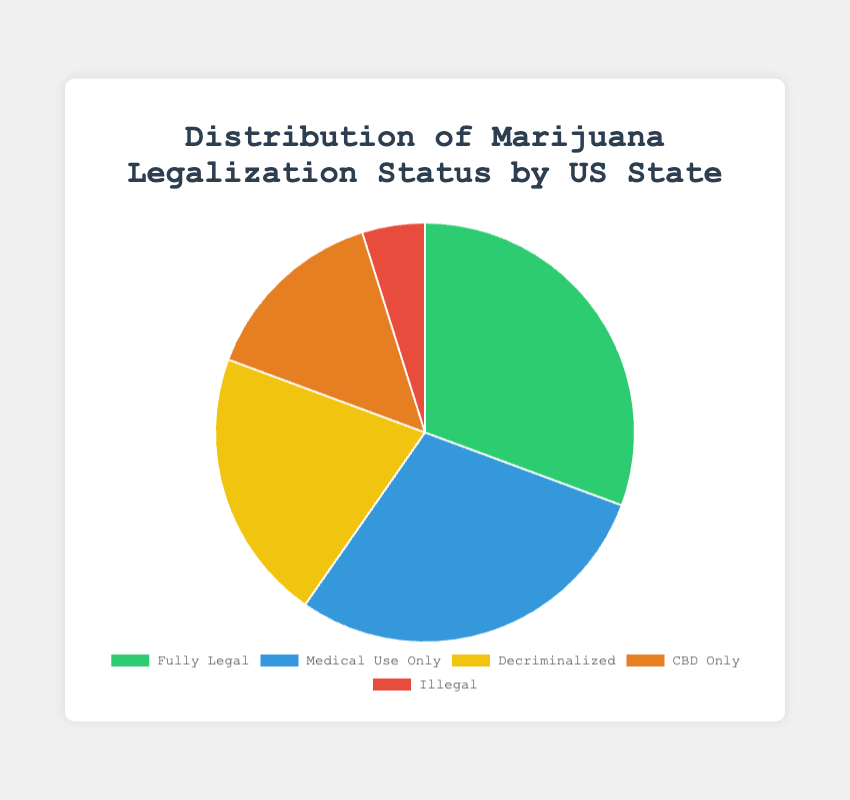What's the proportion of states where marijuana is fully legal compared to those where it's illegal? To find the proportion, compare the number of states where marijuana is fully legal (19) with those where it is illegal (3). The proportion is found by dividing the number of fully legal states by the number of illegal states. \( \frac{19}{3} \approx 6.33 \)
Answer: 6.33 Which category has the highest number of states? The category with the highest number has the biggest section in the pie chart. From the data, "Fully Legal" has the highest count with 19 states.
Answer: Fully Legal How many more states have medical use only legalization compared to those where it's decriminalized? Subtract the number of states where it is decriminalized (13) from the number of states where only medical use is legal (18). \( 18 - 13 = 5 \)
Answer: 5 What percentage of states have CBD Only legalization? To find the percentage, divide the number of states with CBD Only legalization (9) by the total number of states (19 + 18 + 13 + 9 + 3 = 62) and multiply by 100. \( \frac{9}{62} \times 100 \approx 14.52 \% \)
Answer: 14.52% If a state is chosen at random, what's the probability that it is either Fully Legal or Medical Use Only? Sum the number of states that are Fully Legal (19) and Medical Use Only (18) and divide by the total number of states (62). \( \frac{19 + 18}{62} \approx 0.60 \)
Answer: 0.60 Which visual attribute indicates the states where marijuana is illegal? The visual attribute is the color used in the pie chart. States where marijuana is illegal are represented by the red section.
Answer: Red How many states fall into categories that allow some form of marijuana usage (Fully Legal, Medical Use Only, Decriminalized, CBD Only)? Add the number of states in the categories: Fully Legal (19), Medical Use Only (18), Decriminalized (13), and CBD Only (9). \( 19 + 18 + 13 + 9 = 59 \)
Answer: 59 What is the least common legal status for marijuana among the states? The smallest section of the pie chart represents the least common status, which from the data is "Illegal," with only 3 states.
Answer: Illegal Is the number of states where marijuana is decriminalized greater than those where it is CBD only? Compare the numbers. There are 13 states where it is decriminalized and 9 states where it is CBD Only. Since 13 is greater than 9, the answer is yes.
Answer: Yes 